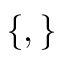<formula> <loc_0><loc_0><loc_500><loc_500>\{ , \}</formula> 